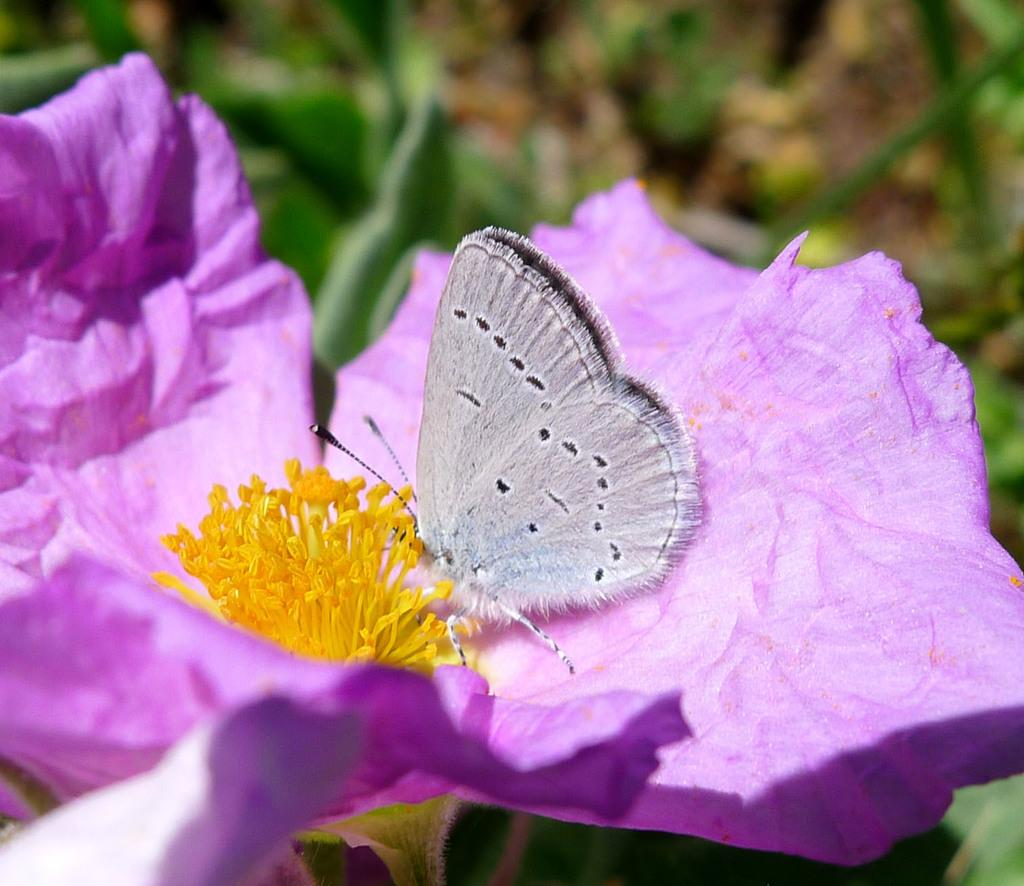What type of flower is present in the image? There is a violet color flower in the image. Is there any other living organism interacting with the flower? Yes, there is a butterfly on the flower. What can be observed in the background of the image? The background of the image is green and blurry. Can you see any trails left by the butterfly in the sand in the image? There is no sand present in the image, and therefore no trails left by the butterfly can be observed. 